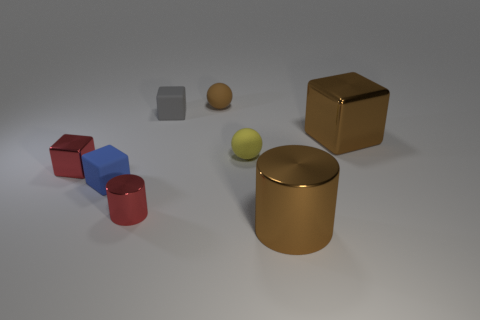The small shiny object that is the same color as the small metallic block is what shape?
Provide a succinct answer. Cylinder. What number of metal objects are cylinders or small brown balls?
Provide a succinct answer. 2. What material is the red thing to the right of the shiny thing that is to the left of the red cylinder?
Provide a succinct answer. Metal. Is the number of tiny rubber objects in front of the yellow matte thing greater than the number of small blue shiny balls?
Your answer should be compact. Yes. Are there any tiny blue cylinders that have the same material as the large cylinder?
Your response must be concise. No. There is a red metal object to the left of the blue matte cube; does it have the same shape as the blue thing?
Your answer should be compact. Yes. What number of brown balls are in front of the brown object in front of the large brown metallic object that is on the right side of the large brown cylinder?
Provide a short and direct response. 0. Are there fewer tiny gray matte blocks behind the small gray object than cylinders to the left of the big brown cylinder?
Offer a terse response. Yes. There is another rubber object that is the same shape as the tiny brown rubber object; what is its color?
Provide a succinct answer. Yellow. The blue cube has what size?
Ensure brevity in your answer.  Small. 